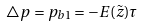Convert formula to latex. <formula><loc_0><loc_0><loc_500><loc_500>\triangle p = p _ { b 1 } = - E ( \tilde { z } ) \tau</formula> 